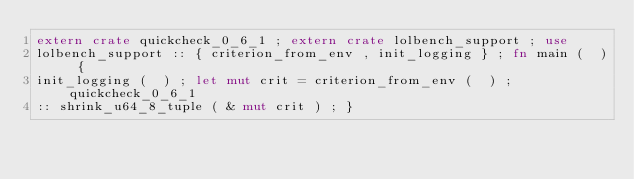Convert code to text. <code><loc_0><loc_0><loc_500><loc_500><_Rust_>extern crate quickcheck_0_6_1 ; extern crate lolbench_support ; use
lolbench_support :: { criterion_from_env , init_logging } ; fn main (  ) {
init_logging (  ) ; let mut crit = criterion_from_env (  ) ; quickcheck_0_6_1
:: shrink_u64_8_tuple ( & mut crit ) ; }</code> 